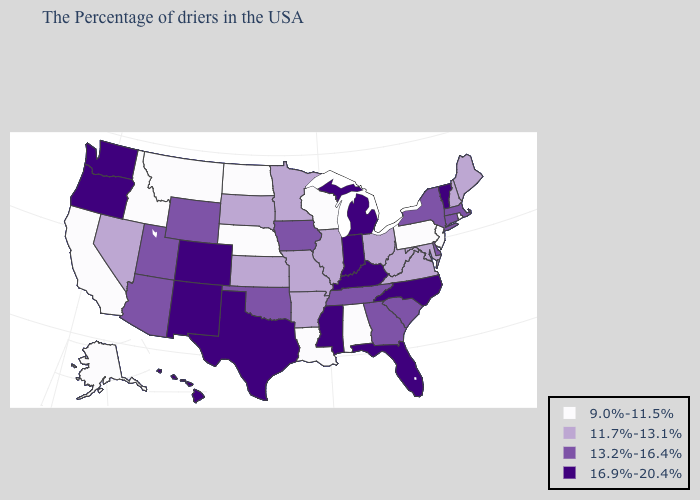What is the value of California?
Answer briefly. 9.0%-11.5%. Name the states that have a value in the range 11.7%-13.1%?
Concise answer only. Maine, New Hampshire, Maryland, Virginia, West Virginia, Ohio, Illinois, Missouri, Arkansas, Minnesota, Kansas, South Dakota, Nevada. What is the value of Michigan?
Give a very brief answer. 16.9%-20.4%. Name the states that have a value in the range 11.7%-13.1%?
Short answer required. Maine, New Hampshire, Maryland, Virginia, West Virginia, Ohio, Illinois, Missouri, Arkansas, Minnesota, Kansas, South Dakota, Nevada. Is the legend a continuous bar?
Give a very brief answer. No. Among the states that border Kentucky , does Tennessee have the lowest value?
Concise answer only. No. Does Maine have the lowest value in the USA?
Answer briefly. No. Does Alabama have the lowest value in the South?
Concise answer only. Yes. What is the value of Florida?
Answer briefly. 16.9%-20.4%. What is the highest value in the South ?
Keep it brief. 16.9%-20.4%. Name the states that have a value in the range 11.7%-13.1%?
Quick response, please. Maine, New Hampshire, Maryland, Virginia, West Virginia, Ohio, Illinois, Missouri, Arkansas, Minnesota, Kansas, South Dakota, Nevada. Does the map have missing data?
Answer briefly. No. What is the lowest value in the USA?
Give a very brief answer. 9.0%-11.5%. Name the states that have a value in the range 13.2%-16.4%?
Give a very brief answer. Massachusetts, Connecticut, New York, Delaware, South Carolina, Georgia, Tennessee, Iowa, Oklahoma, Wyoming, Utah, Arizona. Which states have the lowest value in the USA?
Give a very brief answer. Rhode Island, New Jersey, Pennsylvania, Alabama, Wisconsin, Louisiana, Nebraska, North Dakota, Montana, Idaho, California, Alaska. 